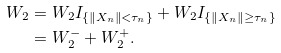<formula> <loc_0><loc_0><loc_500><loc_500>W _ { 2 } & = W _ { 2 } I _ { \left \{ \left \| X _ { n } \right \| < \tau _ { n } \right \} } + W _ { 2 } I _ { \left \{ \left \| X _ { n } \right \| \geq \tau _ { n } \right \} } \\ & = W _ { 2 } ^ { - } + W _ { 2 } ^ { + } .</formula> 